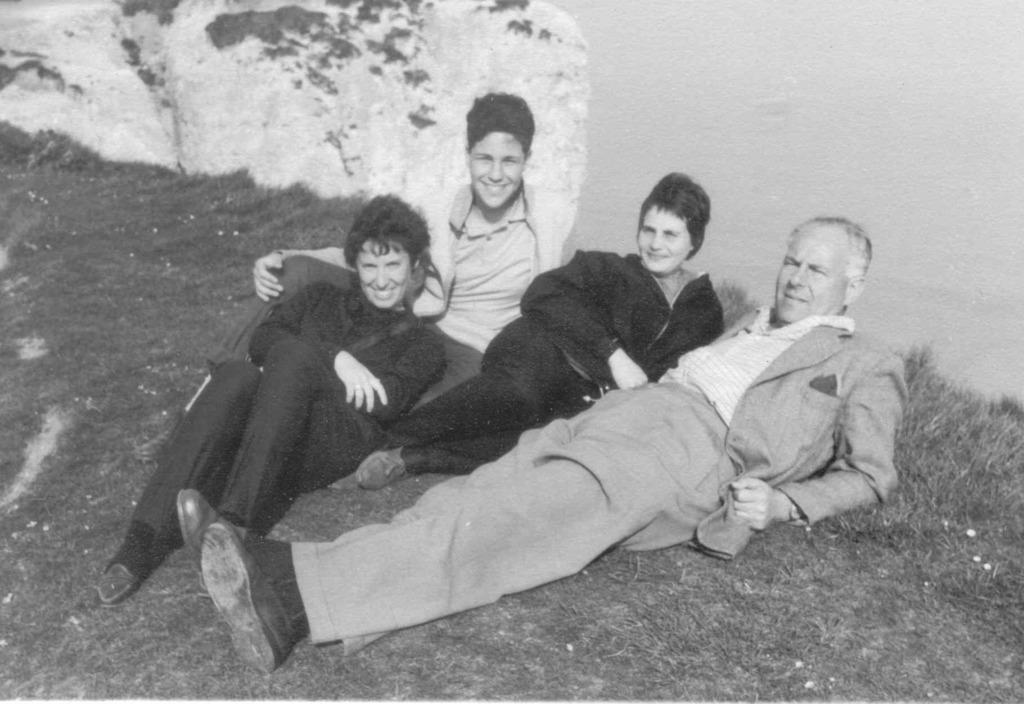What is the color scheme of the image? The image is black and white. What can be seen on the grassland in the image? There are people laying on a grassland in the image. What is visible in the background of the image? There is a wall visible in the background of the image. What type of jar can be seen on the wall in the image? There is no jar present on the wall in the image. What emotion is being expressed by the people in the image? The image is black and white, so it's impossible to determine the emotions of the people based on their facial expressions. 